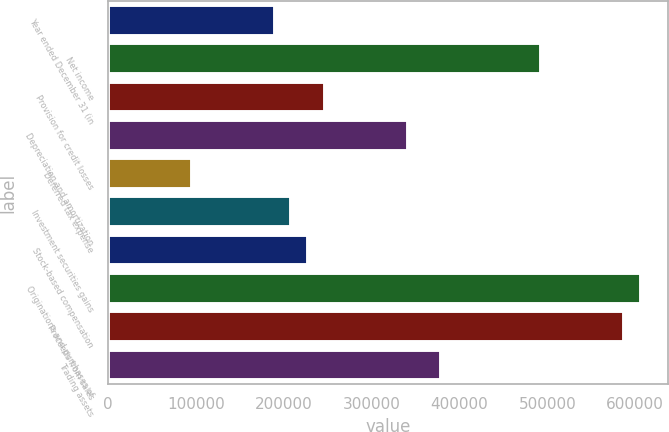Convert chart to OTSL. <chart><loc_0><loc_0><loc_500><loc_500><bar_chart><fcel>Year ended December 31 (in<fcel>Net income<fcel>Provision for credit losses<fcel>Depreciation and amortization<fcel>Deferred tax expense<fcel>Investment securities gains<fcel>Stock-based compensation<fcel>Originations and purchases of<fcel>Proceeds from sales<fcel>Trading assets<nl><fcel>189630<fcel>493032<fcel>246518<fcel>341331<fcel>94817<fcel>208593<fcel>227555<fcel>606807<fcel>587845<fcel>379256<nl></chart> 